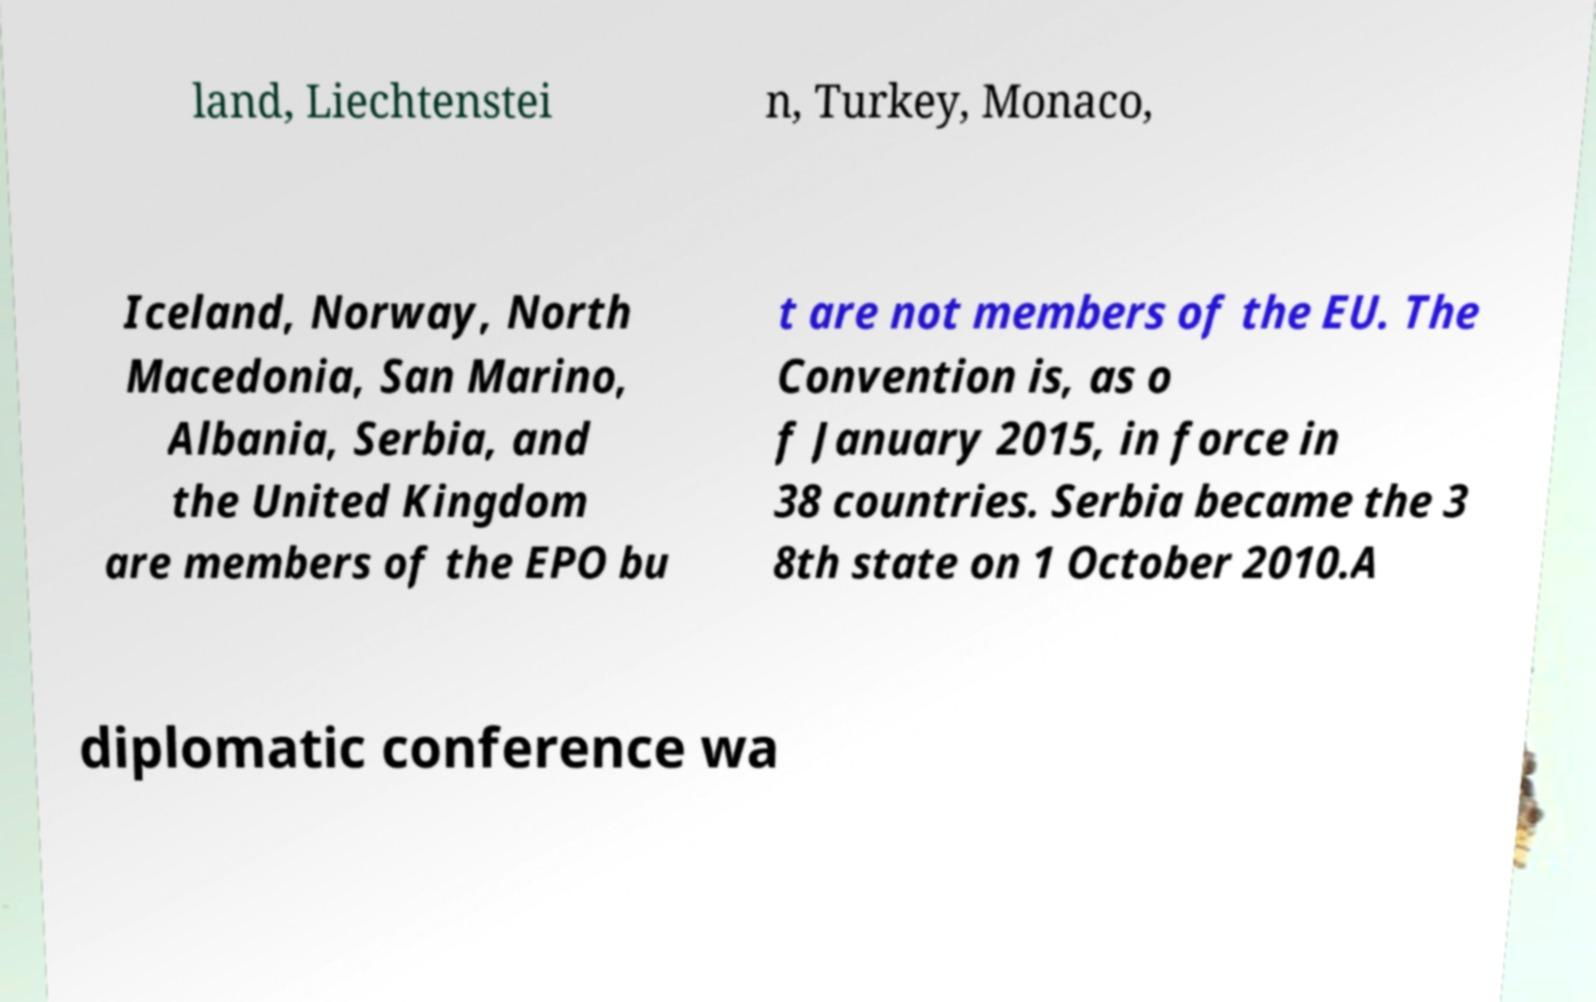For documentation purposes, I need the text within this image transcribed. Could you provide that? land, Liechtenstei n, Turkey, Monaco, Iceland, Norway, North Macedonia, San Marino, Albania, Serbia, and the United Kingdom are members of the EPO bu t are not members of the EU. The Convention is, as o f January 2015, in force in 38 countries. Serbia became the 3 8th state on 1 October 2010.A diplomatic conference wa 